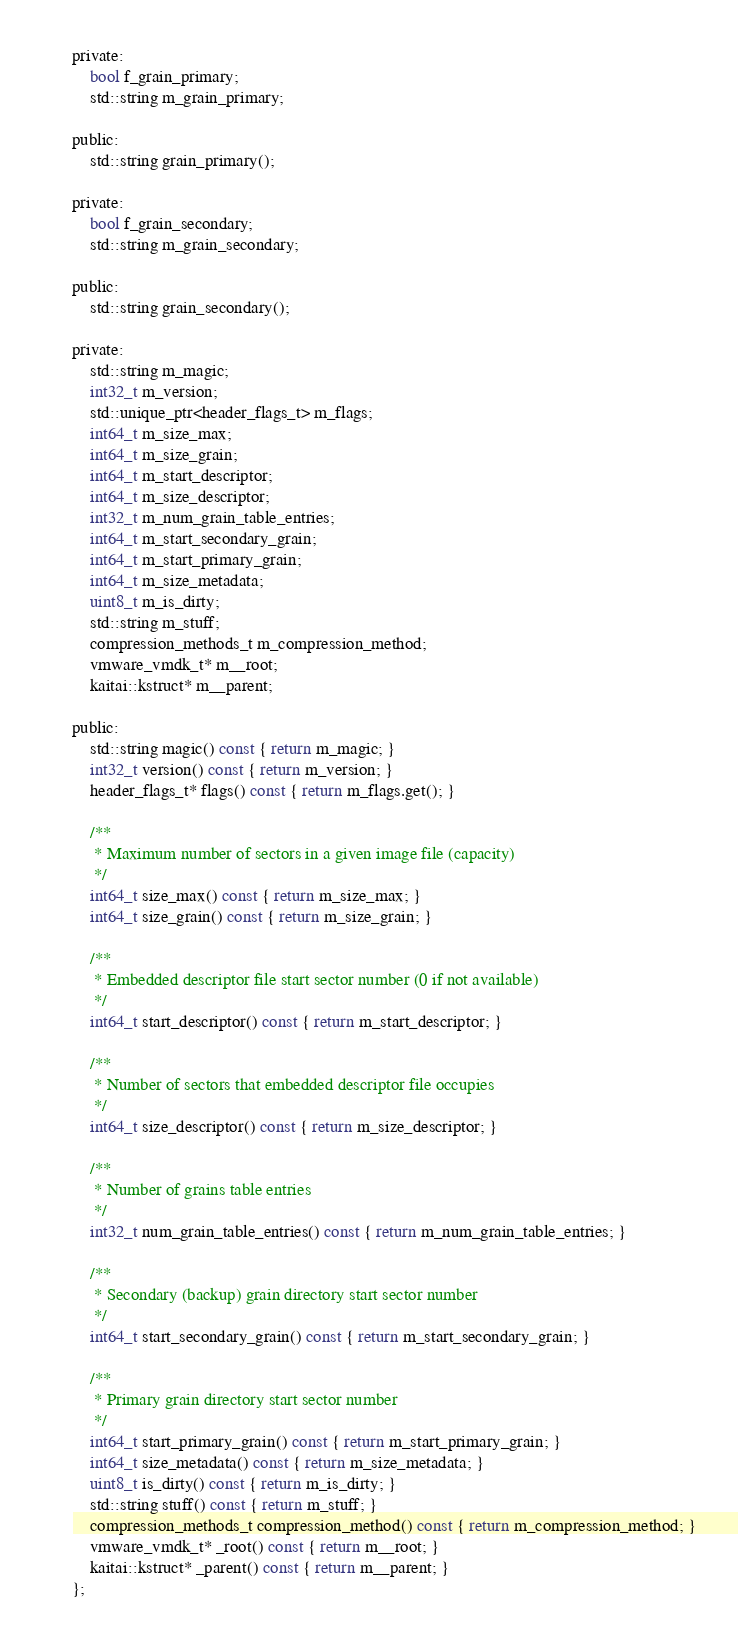Convert code to text. <code><loc_0><loc_0><loc_500><loc_500><_C_>
private:
    bool f_grain_primary;
    std::string m_grain_primary;

public:
    std::string grain_primary();

private:
    bool f_grain_secondary;
    std::string m_grain_secondary;

public:
    std::string grain_secondary();

private:
    std::string m_magic;
    int32_t m_version;
    std::unique_ptr<header_flags_t> m_flags;
    int64_t m_size_max;
    int64_t m_size_grain;
    int64_t m_start_descriptor;
    int64_t m_size_descriptor;
    int32_t m_num_grain_table_entries;
    int64_t m_start_secondary_grain;
    int64_t m_start_primary_grain;
    int64_t m_size_metadata;
    uint8_t m_is_dirty;
    std::string m_stuff;
    compression_methods_t m_compression_method;
    vmware_vmdk_t* m__root;
    kaitai::kstruct* m__parent;

public:
    std::string magic() const { return m_magic; }
    int32_t version() const { return m_version; }
    header_flags_t* flags() const { return m_flags.get(); }

    /**
     * Maximum number of sectors in a given image file (capacity)
     */
    int64_t size_max() const { return m_size_max; }
    int64_t size_grain() const { return m_size_grain; }

    /**
     * Embedded descriptor file start sector number (0 if not available)
     */
    int64_t start_descriptor() const { return m_start_descriptor; }

    /**
     * Number of sectors that embedded descriptor file occupies
     */
    int64_t size_descriptor() const { return m_size_descriptor; }

    /**
     * Number of grains table entries
     */
    int32_t num_grain_table_entries() const { return m_num_grain_table_entries; }

    /**
     * Secondary (backup) grain directory start sector number
     */
    int64_t start_secondary_grain() const { return m_start_secondary_grain; }

    /**
     * Primary grain directory start sector number
     */
    int64_t start_primary_grain() const { return m_start_primary_grain; }
    int64_t size_metadata() const { return m_size_metadata; }
    uint8_t is_dirty() const { return m_is_dirty; }
    std::string stuff() const { return m_stuff; }
    compression_methods_t compression_method() const { return m_compression_method; }
    vmware_vmdk_t* _root() const { return m__root; }
    kaitai::kstruct* _parent() const { return m__parent; }
};
</code> 